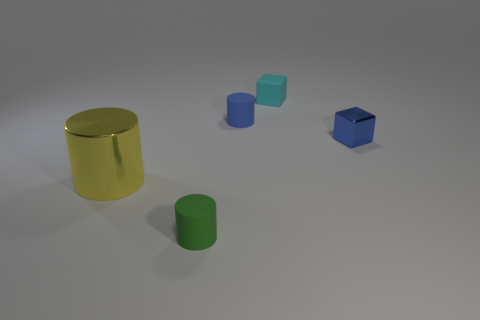Which objects in this image have a cylindrical shape? The two objects with a cylindrical shape are the gold cylinder on the left and the blue cylinder in the middle. 